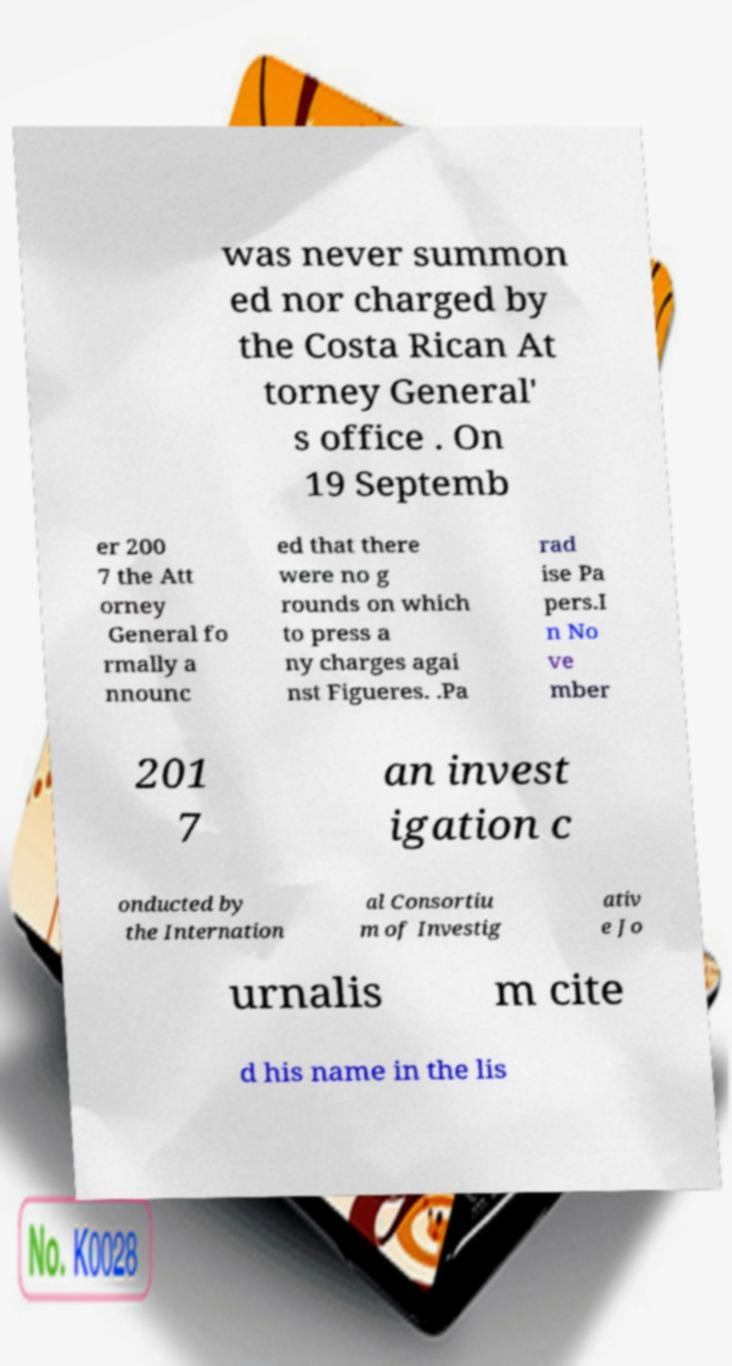What messages or text are displayed in this image? I need them in a readable, typed format. was never summon ed nor charged by the Costa Rican At torney General' s office . On 19 Septemb er 200 7 the Att orney General fo rmally a nnounc ed that there were no g rounds on which to press a ny charges agai nst Figueres. .Pa rad ise Pa pers.I n No ve mber 201 7 an invest igation c onducted by the Internation al Consortiu m of Investig ativ e Jo urnalis m cite d his name in the lis 